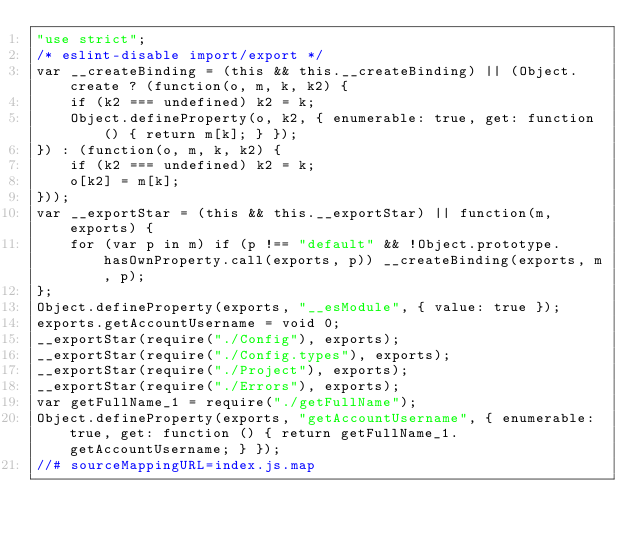<code> <loc_0><loc_0><loc_500><loc_500><_JavaScript_>"use strict";
/* eslint-disable import/export */
var __createBinding = (this && this.__createBinding) || (Object.create ? (function(o, m, k, k2) {
    if (k2 === undefined) k2 = k;
    Object.defineProperty(o, k2, { enumerable: true, get: function() { return m[k]; } });
}) : (function(o, m, k, k2) {
    if (k2 === undefined) k2 = k;
    o[k2] = m[k];
}));
var __exportStar = (this && this.__exportStar) || function(m, exports) {
    for (var p in m) if (p !== "default" && !Object.prototype.hasOwnProperty.call(exports, p)) __createBinding(exports, m, p);
};
Object.defineProperty(exports, "__esModule", { value: true });
exports.getAccountUsername = void 0;
__exportStar(require("./Config"), exports);
__exportStar(require("./Config.types"), exports);
__exportStar(require("./Project"), exports);
__exportStar(require("./Errors"), exports);
var getFullName_1 = require("./getFullName");
Object.defineProperty(exports, "getAccountUsername", { enumerable: true, get: function () { return getFullName_1.getAccountUsername; } });
//# sourceMappingURL=index.js.map</code> 